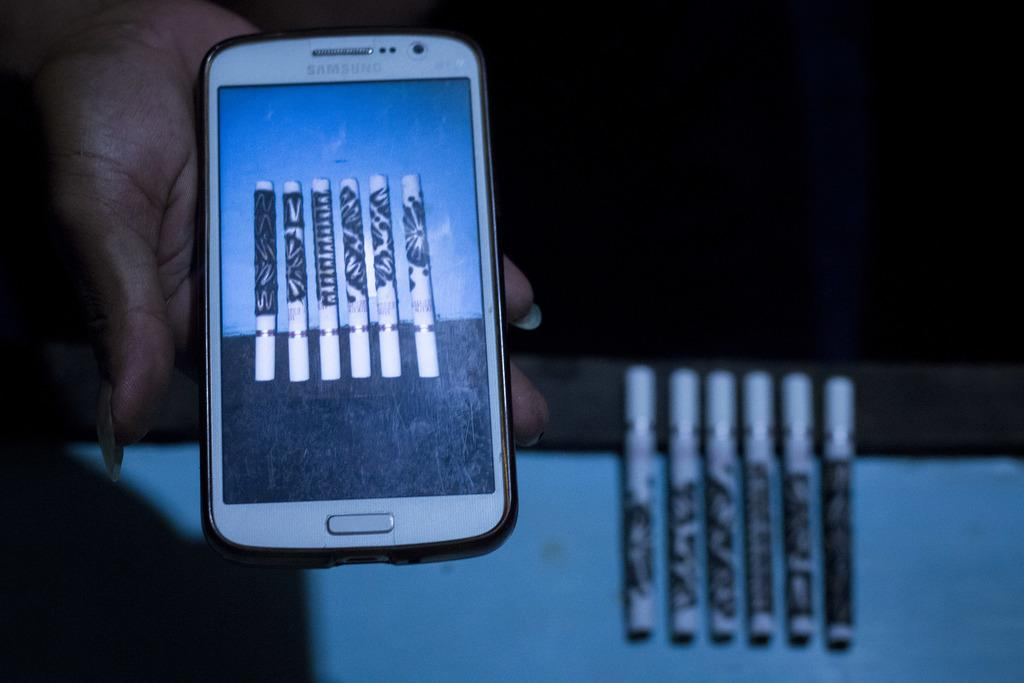Provide a one-sentence caption for the provided image. A samsung smartphone shows 6 cigarette shaped vapers while the vapers are displayed behind it. 